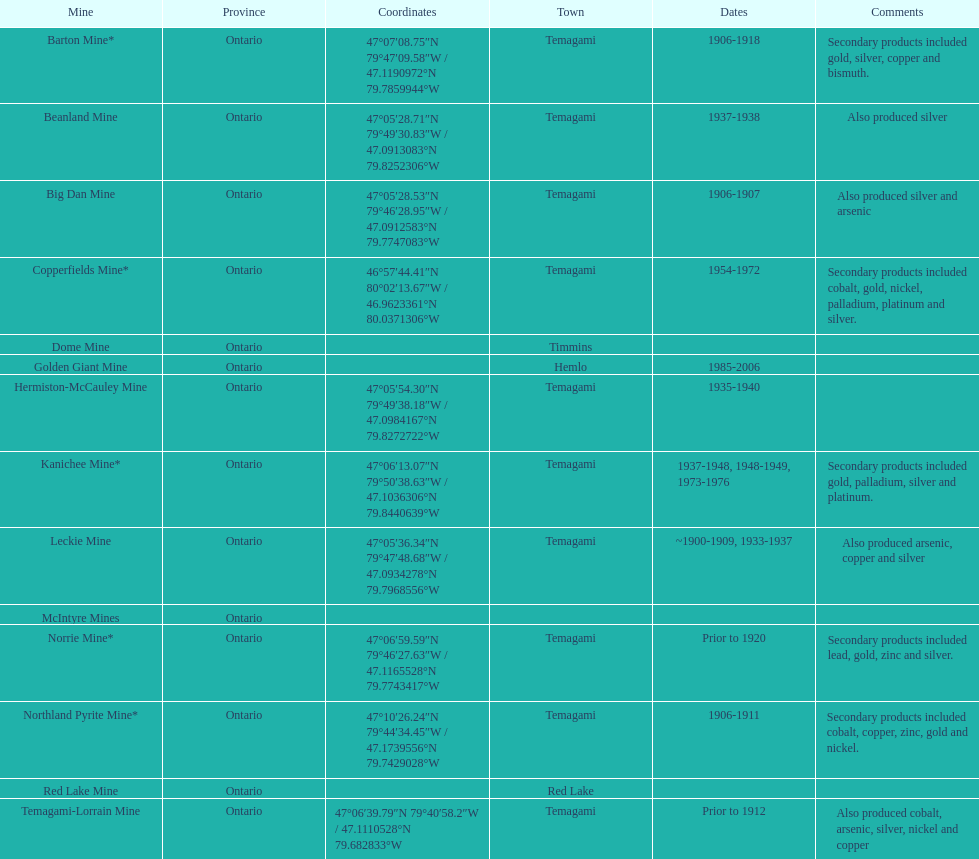How many mines were in temagami? 10. 